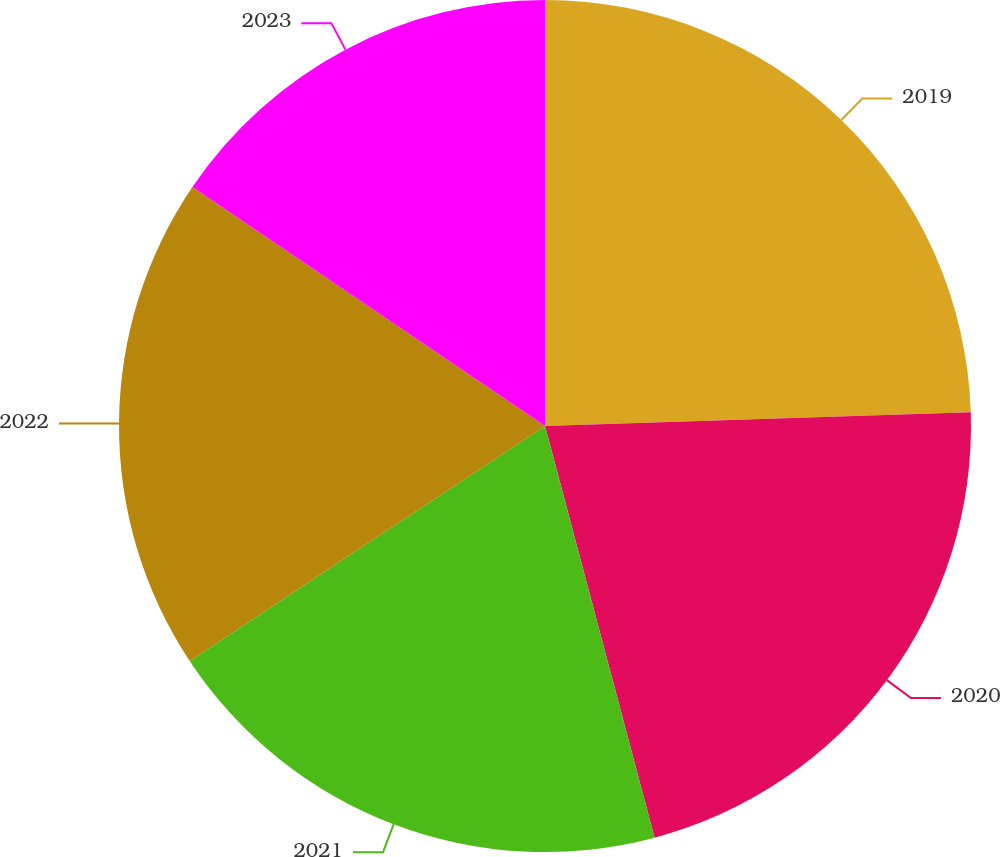<chart> <loc_0><loc_0><loc_500><loc_500><pie_chart><fcel>2019<fcel>2020<fcel>2021<fcel>2022<fcel>2023<nl><fcel>24.49%<fcel>21.37%<fcel>19.84%<fcel>18.78%<fcel>15.52%<nl></chart> 